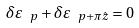Convert formula to latex. <formula><loc_0><loc_0><loc_500><loc_500>\delta \varepsilon _ { \ p } + \delta \varepsilon _ { \ p + \pi \hat { z } } = 0</formula> 